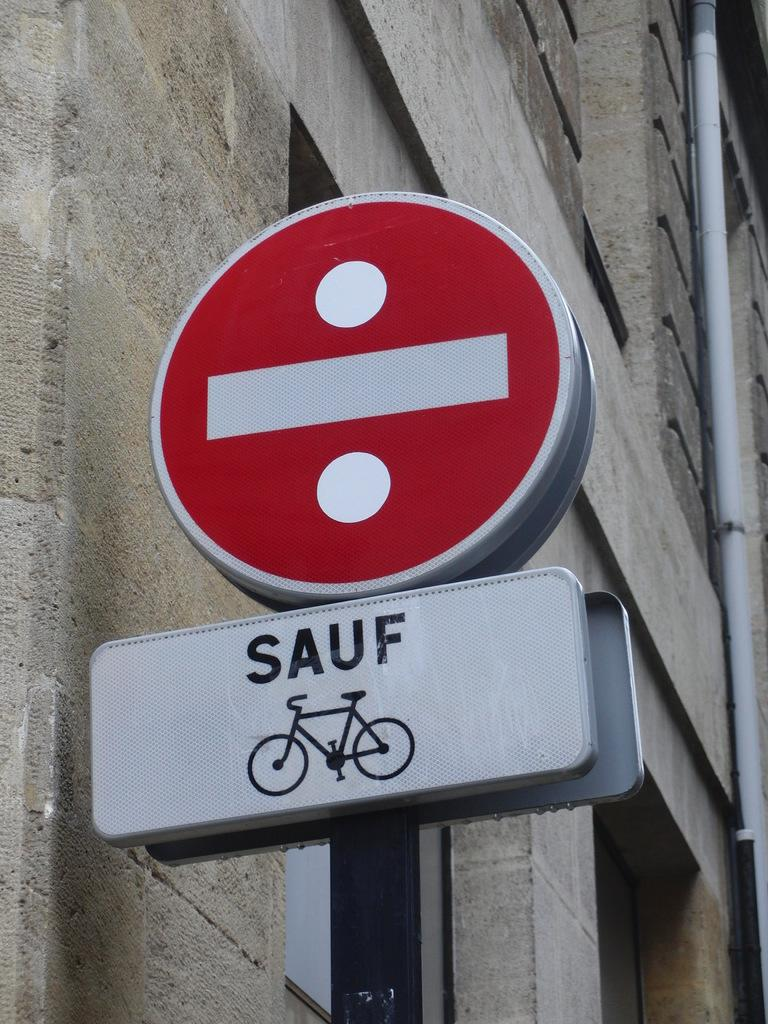Provide a one-sentence caption for the provided image. A red and white sign with another white sign below it that says SAUF. 